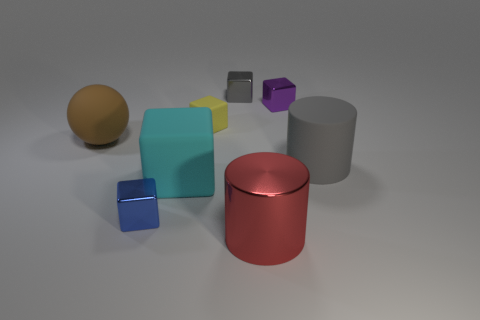Is there a cyan shiny cube that has the same size as the cyan object?
Make the answer very short. No. There is a small thing right of the large metallic cylinder; what is its color?
Your answer should be very brief. Purple. What is the shape of the rubber thing that is to the right of the cyan block and in front of the yellow matte cube?
Offer a very short reply. Cylinder. How many large red objects are the same shape as the gray metallic thing?
Your response must be concise. 0. How many matte objects are there?
Keep it short and to the point. 4. What size is the object that is both on the left side of the yellow rubber thing and behind the gray rubber thing?
Offer a very short reply. Large. The rubber object that is the same size as the purple metallic thing is what shape?
Your answer should be very brief. Cube. Is there a tiny rubber object to the right of the big cylinder behind the large red object?
Offer a terse response. No. What color is the other large thing that is the same shape as the gray rubber thing?
Give a very brief answer. Red. Does the large rubber object to the right of the small gray shiny block have the same color as the big metallic cylinder?
Your answer should be very brief. No. 